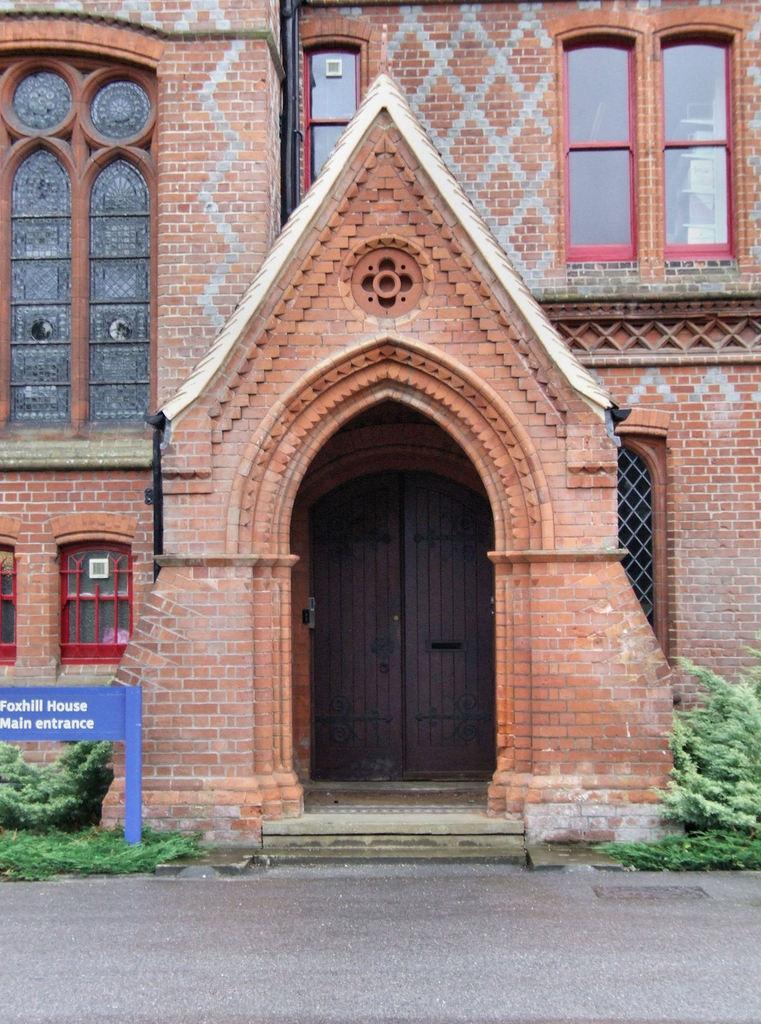How would you summarize this image in a sentence or two? In this image we can see a building with doors and windows and there are some plants and we can see a board with text on the left side of the image. 